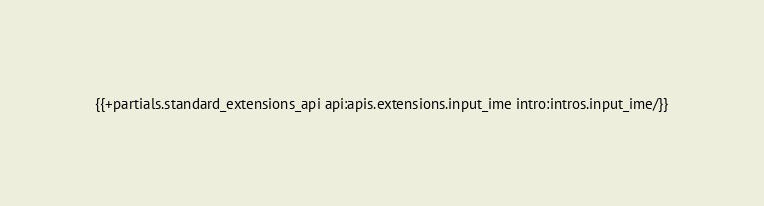Convert code to text. <code><loc_0><loc_0><loc_500><loc_500><_HTML_>{{+partials.standard_extensions_api api:apis.extensions.input_ime intro:intros.input_ime/}}
</code> 